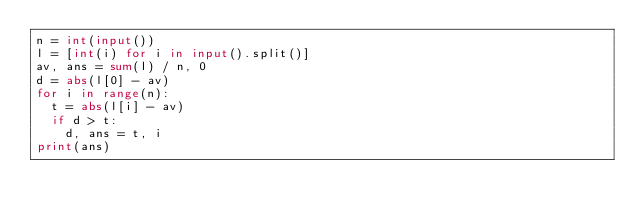<code> <loc_0><loc_0><loc_500><loc_500><_Python_>n = int(input())
l = [int(i) for i in input().split()]
av, ans = sum(l) / n, 0
d = abs(l[0] - av)
for i in range(n):
  t = abs(l[i] - av)
  if d > t:
    d, ans = t, i
print(ans)</code> 